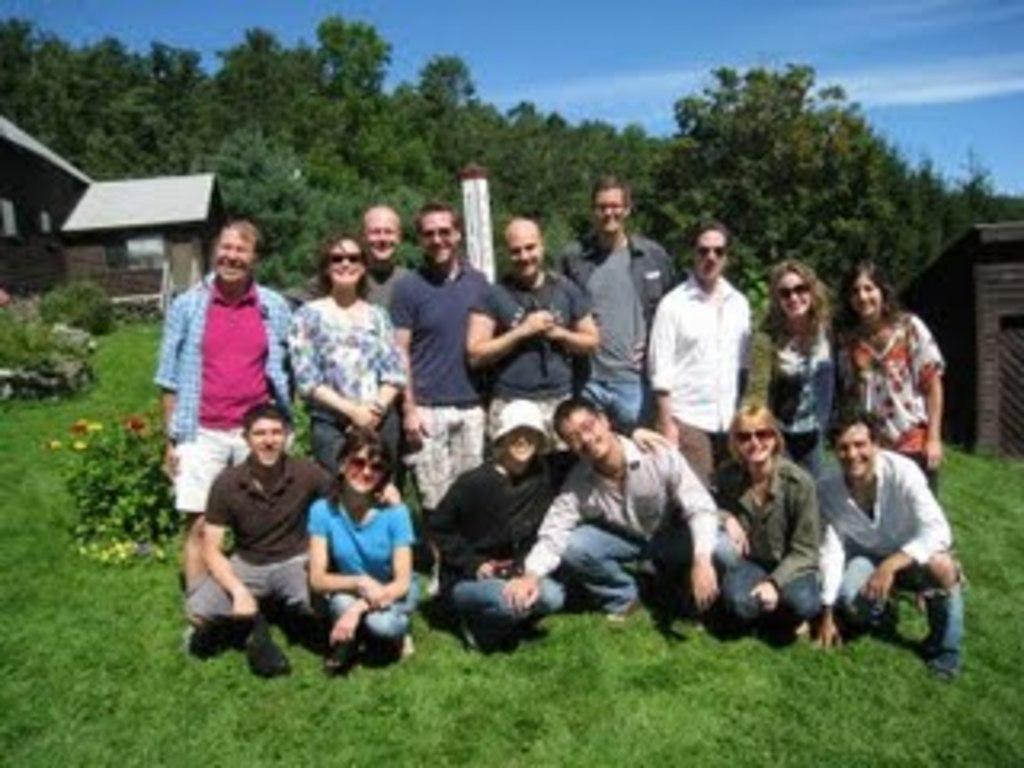How many people are in the image? There is a group of people in the image. What is the surface the people are standing on? The people are on grass. What type of plants can be seen in the image? Flowering plants are present in the image. What structure can be seen in the image? There is a pole in the image. What type of buildings are visible in the image? Houses are visible in the image. What natural elements are present in the image? Trees are present in the image. What part of the environment is visible in the image? The sky is visible in the image. Based on the presence of the sun and the visibility of the sky, can we determine the time of day the image was taken? The image was likely taken during the day. Are there any fairies visible in the image? There are no fairies present in the image. What type of debt is being discussed by the people in the image? There is no indication of any debt-related discussion in the image. 